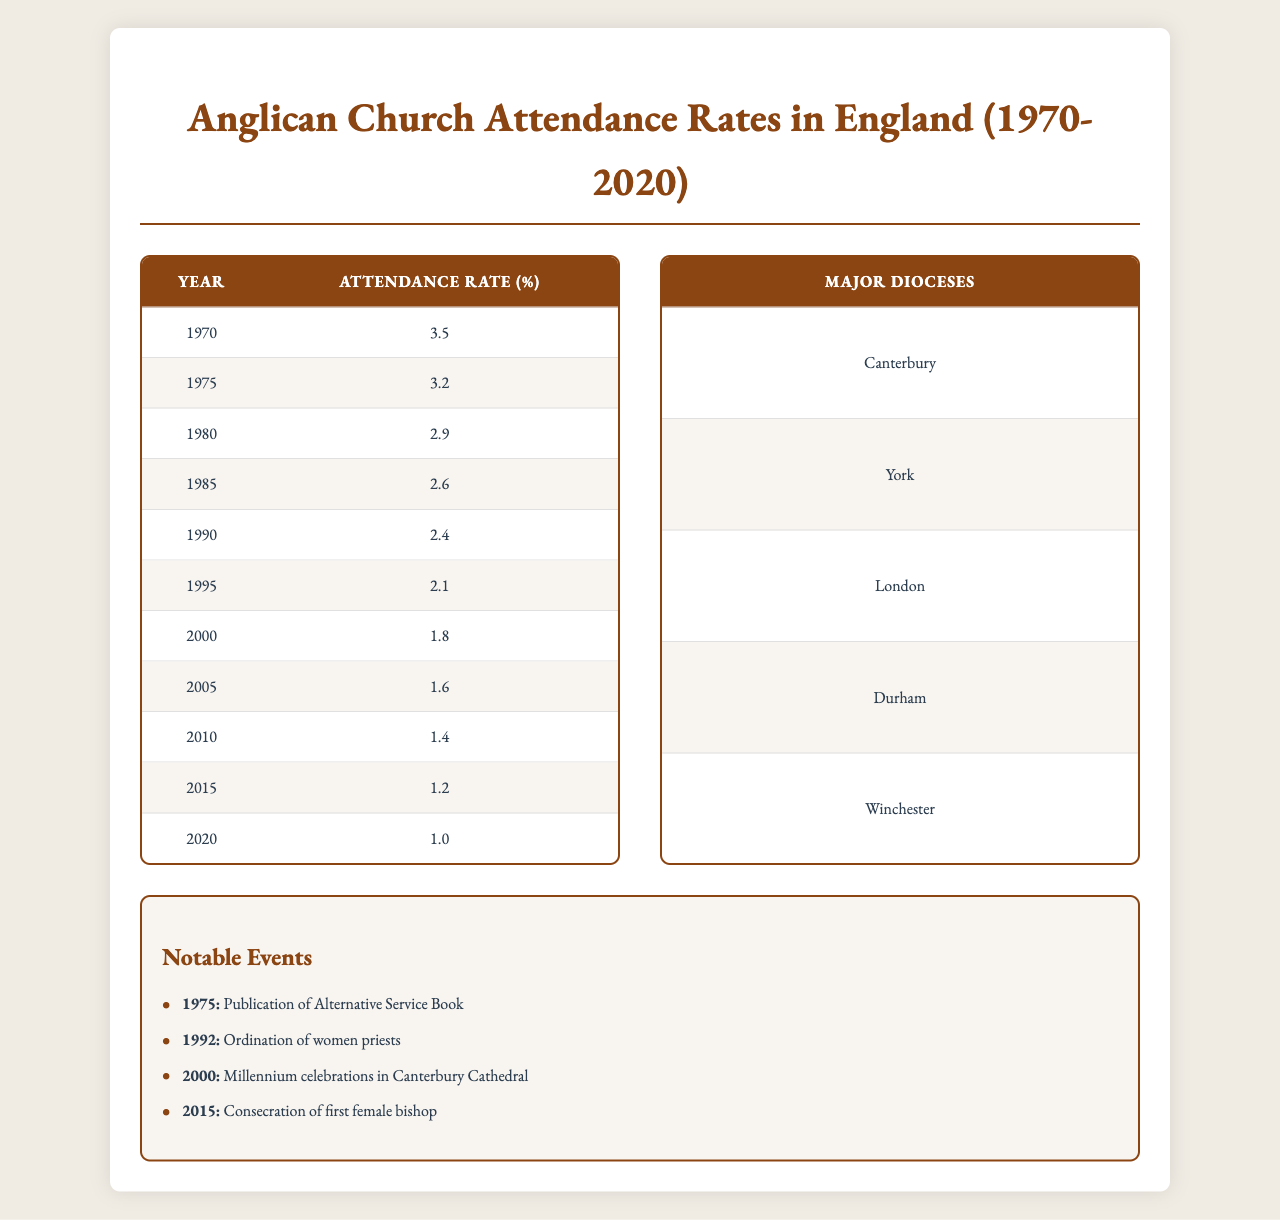What was the attendance rate in 1990? The attendance rate for the year 1990 is listed directly in the table under the column for attendance rates, which shows 2.4%.
Answer: 2.4% What notable event occurred in 1992? The notable event for the year 1992, mentioned in the notable events section, is the "Ordination of women priests."
Answer: Ordination of women priests Which year had the highest attendance rate? The year with the highest attendance rate is 1970, as indicated by the data showing an attendance rate of 3.5%.
Answer: 1970 What was the average attendance rate from 1970 to 2020? To calculate the average, we first sum the attendance rates from each year (3.5 + 3.2 + 2.9 + 2.6 + 2.4 + 2.1 + 1.8 + 1.6 + 1.4 + 1.2 + 1.0 = 22.7) and then divide by the number of years (11), resulting in an average of approximately 2.07%.
Answer: 2.07% Was the attendance rate lower in 2020 compared to 1970? Yes, the attendance rate in 2020 was 1.0%, which is lower than the rate of 3.5% in 1970.
Answer: Yes How much has the attendance rate decreased from 1970 to 2020? The decrease in attendance rate is calculated by subtracting the 2020 rate (1.0%) from the 1970 rate (3.5%), leading to a decrease of 2.5 percentage points.
Answer: 2.5 percentage points What is the trend in attendance rates from 1970 to 2020? By observing the attendance rates listed over the years, one can see that there is a consistent decrease from 3.5% in 1970 down to 1.0% in 2020, indicating a declining trend.
Answer: Declining trend Which year had the lowest attendance rate? The lowest attendance rate is found in 2020, where the rate is recorded as 1.0%.
Answer: 2020 Which diocese is listed first in the table? The first diocese listed in the table is "Canterbury."
Answer: Canterbury Did the attendance rates show any recovery from 2000 to 2015? No, the attendance rates continued to decline during that period, going from 1.8% in 2000 down to 1.2% in 2015.
Answer: No 